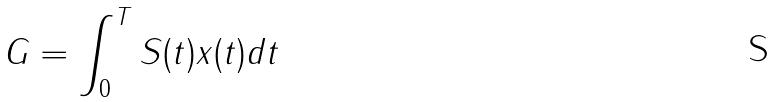Convert formula to latex. <formula><loc_0><loc_0><loc_500><loc_500>G = \int _ { 0 } ^ { T } S ( t ) x ( t ) d t</formula> 